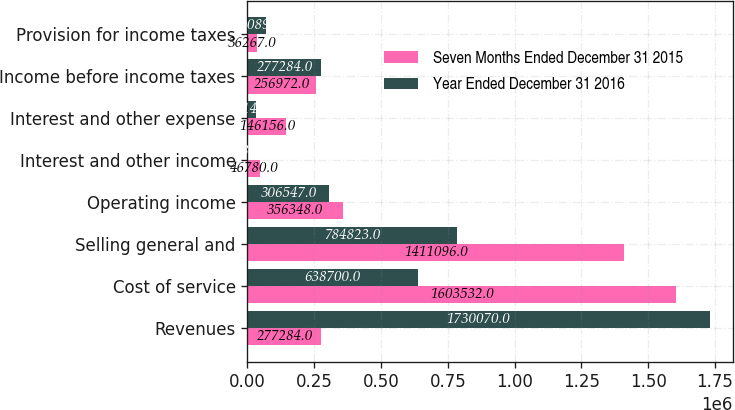<chart> <loc_0><loc_0><loc_500><loc_500><stacked_bar_chart><ecel><fcel>Revenues<fcel>Cost of service<fcel>Selling general and<fcel>Operating income<fcel>Interest and other income<fcel>Interest and other expense<fcel>Income before income taxes<fcel>Provision for income taxes<nl><fcel>Seven Months Ended December 31 2015<fcel>277284<fcel>1.60353e+06<fcel>1.4111e+06<fcel>356348<fcel>46780<fcel>146156<fcel>256972<fcel>36267<nl><fcel>Year Ended December 31 2016<fcel>1.73007e+06<fcel>638700<fcel>784823<fcel>306547<fcel>2886<fcel>32149<fcel>277284<fcel>70089<nl></chart> 